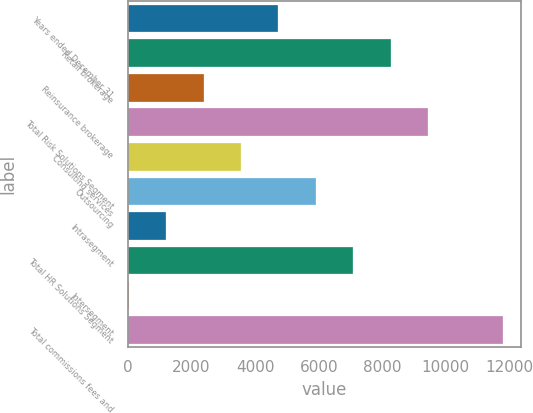Convert chart to OTSL. <chart><loc_0><loc_0><loc_500><loc_500><bar_chart><fcel>Years ended December 31<fcel>Retail brokerage<fcel>Reinsurance brokerage<fcel>Total Risk Solutions Segment<fcel>Consulting services<fcel>Outsourcing<fcel>Intrasegment<fcel>Total HR Solutions Segment<fcel>Intersegment<fcel>Total commissions fees and<nl><fcel>4733.4<fcel>8260.2<fcel>2382.2<fcel>9435.8<fcel>3557.8<fcel>5909<fcel>1206.6<fcel>7084.6<fcel>31<fcel>11787<nl></chart> 